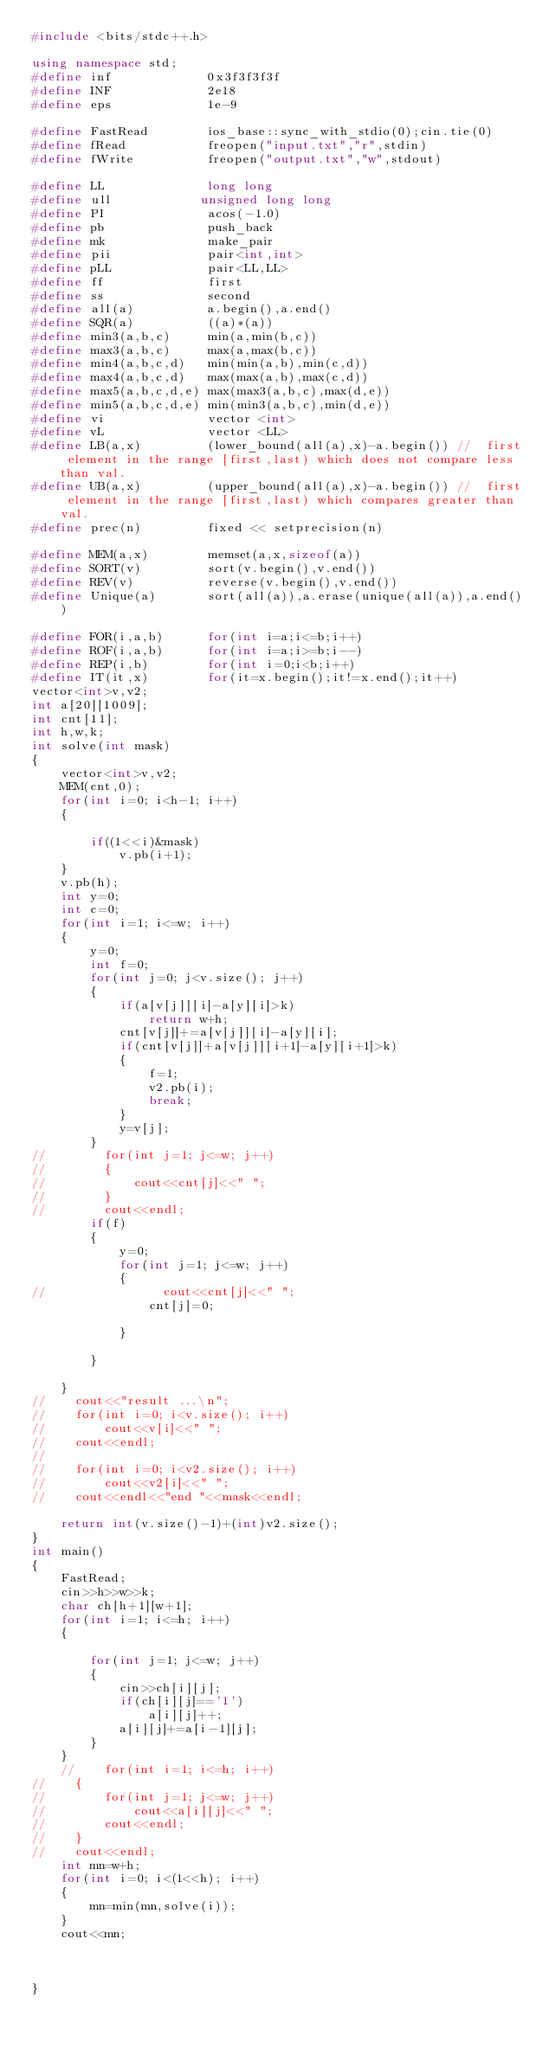Convert code to text. <code><loc_0><loc_0><loc_500><loc_500><_C++_>#include <bits/stdc++.h>

using namespace std;
#define inf             0x3f3f3f3f
#define INF             2e18
#define eps             1e-9

#define FastRead        ios_base::sync_with_stdio(0);cin.tie(0)
#define fRead           freopen("input.txt","r",stdin)
#define fWrite          freopen("output.txt","w",stdout)

#define LL              long long
#define ull            unsigned long long
#define PI              acos(-1.0)
#define pb              push_back
#define mk              make_pair
#define pii             pair<int,int>
#define pLL             pair<LL,LL>
#define ff              first
#define ss              second
#define all(a)          a.begin(),a.end()
#define SQR(a)          ((a)*(a))
#define min3(a,b,c)     min(a,min(b,c))
#define max3(a,b,c)     max(a,max(b,c))
#define min4(a,b,c,d)   min(min(a,b),min(c,d))
#define max4(a,b,c,d)   max(max(a,b),max(c,d))
#define max5(a,b,c,d,e) max(max3(a,b,c),max(d,e))
#define min5(a,b,c,d,e) min(min3(a,b,c),min(d,e))
#define vi              vector <int>
#define vL              vector <LL>
#define LB(a,x)         (lower_bound(all(a),x)-a.begin()) //  first element in the range [first,last) which does not compare less than val.
#define UB(a,x)         (upper_bound(all(a),x)-a.begin()) //  first element in the range [first,last) which compares greater than val.
#define prec(n)         fixed << setprecision(n)

#define MEM(a,x)        memset(a,x,sizeof(a))
#define SORT(v)         sort(v.begin(),v.end())
#define REV(v)          reverse(v.begin(),v.end())
#define Unique(a)       sort(all(a)),a.erase(unique(all(a)),a.end())

#define FOR(i,a,b)      for(int i=a;i<=b;i++)
#define ROF(i,a,b)      for(int i=a;i>=b;i--)
#define REP(i,b)        for(int i=0;i<b;i++)
#define IT(it,x)	    for(it=x.begin();it!=x.end();it++)
vector<int>v,v2;
int a[20][1009];
int cnt[11];
int h,w,k;
int solve(int mask)
{
    vector<int>v,v2;
    MEM(cnt,0);
    for(int i=0; i<h-1; i++)
    {

        if((1<<i)&mask)
            v.pb(i+1);
    }
    v.pb(h);
    int y=0;
    int c=0;
    for(int i=1; i<=w; i++)
    {
        y=0;
        int f=0;
        for(int j=0; j<v.size(); j++)
        {
            if(a[v[j]][i]-a[y][i]>k)
                return w+h;
            cnt[v[j]]+=a[v[j]][i]-a[y][i];
            if(cnt[v[j]]+a[v[j]][i+1]-a[y][i+1]>k)
            {
                f=1;
                v2.pb(i);
                break;
            }
            y=v[j];
        }
//        for(int j=1; j<=w; j++)
//        {
//            cout<<cnt[j]<<" ";
//        }
//        cout<<endl;
        if(f)
        {
            y=0;
            for(int j=1; j<=w; j++)
            {
//                cout<<cnt[j]<<" ";
                cnt[j]=0;

            }

        }

    }
//    cout<<"result ...\n";
//    for(int i=0; i<v.size(); i++)
//        cout<<v[i]<<" ";
//    cout<<endl;
//
//    for(int i=0; i<v2.size(); i++)
//        cout<<v2[i]<<" ";
//    cout<<endl<<"end "<<mask<<endl;

    return int(v.size()-1)+(int)v2.size();
}
int main()
{
    FastRead;
    cin>>h>>w>>k;
    char ch[h+1][w+1];
    for(int i=1; i<=h; i++)
    {

        for(int j=1; j<=w; j++)
        {
            cin>>ch[i][j];
            if(ch[i][j]=='1')
                a[i][j]++;
            a[i][j]+=a[i-1][j];
        }
    }
    //    for(int i=1; i<=h; i++)
//    {
//        for(int j=1; j<=w; j++)
//            cout<<a[i][j]<<" ";
//        cout<<endl;
//    }
//    cout<<endl;
    int mn=w+h;
    for(int i=0; i<(1<<h); i++)
    {
        mn=min(mn,solve(i));
    }
    cout<<mn;



}
</code> 